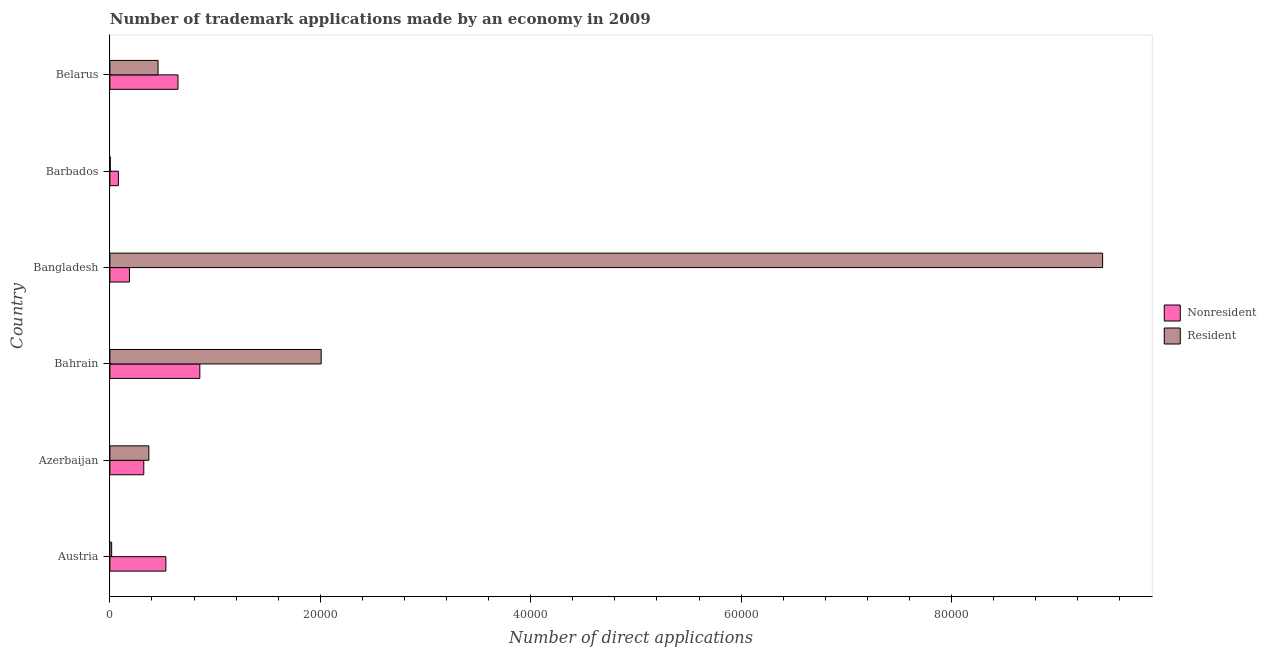Are the number of bars per tick equal to the number of legend labels?
Your answer should be compact. Yes. Are the number of bars on each tick of the Y-axis equal?
Give a very brief answer. Yes. How many bars are there on the 5th tick from the top?
Make the answer very short. 2. How many bars are there on the 2nd tick from the bottom?
Give a very brief answer. 2. What is the label of the 2nd group of bars from the top?
Offer a terse response. Barbados. In how many cases, is the number of bars for a given country not equal to the number of legend labels?
Give a very brief answer. 0. What is the number of trademark applications made by non residents in Azerbaijan?
Give a very brief answer. 3221. Across all countries, what is the maximum number of trademark applications made by residents?
Provide a short and direct response. 9.44e+04. Across all countries, what is the minimum number of trademark applications made by non residents?
Provide a succinct answer. 808. In which country was the number of trademark applications made by residents maximum?
Provide a succinct answer. Bangladesh. In which country was the number of trademark applications made by non residents minimum?
Your answer should be very brief. Barbados. What is the total number of trademark applications made by non residents in the graph?
Offer a very short reply. 2.62e+04. What is the difference between the number of trademark applications made by residents in Austria and that in Barbados?
Offer a terse response. 133. What is the difference between the number of trademark applications made by residents in Bangladesh and the number of trademark applications made by non residents in Belarus?
Make the answer very short. 8.79e+04. What is the average number of trademark applications made by residents per country?
Make the answer very short. 2.05e+04. What is the difference between the number of trademark applications made by non residents and number of trademark applications made by residents in Austria?
Your answer should be compact. 5153. In how many countries, is the number of trademark applications made by non residents greater than 28000 ?
Give a very brief answer. 0. What is the ratio of the number of trademark applications made by non residents in Bahrain to that in Belarus?
Your answer should be compact. 1.32. Is the number of trademark applications made by non residents in Barbados less than that in Belarus?
Your answer should be compact. Yes. What is the difference between the highest and the second highest number of trademark applications made by residents?
Give a very brief answer. 7.43e+04. What is the difference between the highest and the lowest number of trademark applications made by non residents?
Your response must be concise. 7740. Is the sum of the number of trademark applications made by residents in Austria and Bangladesh greater than the maximum number of trademark applications made by non residents across all countries?
Ensure brevity in your answer.  Yes. What does the 1st bar from the top in Austria represents?
Ensure brevity in your answer.  Resident. What does the 2nd bar from the bottom in Bangladesh represents?
Your answer should be very brief. Resident. How many bars are there?
Your response must be concise. 12. Are all the bars in the graph horizontal?
Offer a terse response. Yes. How many countries are there in the graph?
Keep it short and to the point. 6. Are the values on the major ticks of X-axis written in scientific E-notation?
Offer a terse response. No. Does the graph contain grids?
Your answer should be very brief. No. How many legend labels are there?
Your answer should be very brief. 2. What is the title of the graph?
Ensure brevity in your answer.  Number of trademark applications made by an economy in 2009. What is the label or title of the X-axis?
Provide a succinct answer. Number of direct applications. What is the Number of direct applications in Nonresident in Austria?
Ensure brevity in your answer.  5321. What is the Number of direct applications of Resident in Austria?
Ensure brevity in your answer.  168. What is the Number of direct applications of Nonresident in Azerbaijan?
Give a very brief answer. 3221. What is the Number of direct applications in Resident in Azerbaijan?
Provide a succinct answer. 3703. What is the Number of direct applications of Nonresident in Bahrain?
Offer a very short reply. 8548. What is the Number of direct applications in Resident in Bahrain?
Offer a very short reply. 2.01e+04. What is the Number of direct applications of Nonresident in Bangladesh?
Make the answer very short. 1859. What is the Number of direct applications in Resident in Bangladesh?
Provide a short and direct response. 9.44e+04. What is the Number of direct applications in Nonresident in Barbados?
Your answer should be very brief. 808. What is the Number of direct applications in Nonresident in Belarus?
Keep it short and to the point. 6473. What is the Number of direct applications in Resident in Belarus?
Your answer should be very brief. 4578. Across all countries, what is the maximum Number of direct applications of Nonresident?
Offer a very short reply. 8548. Across all countries, what is the maximum Number of direct applications of Resident?
Your response must be concise. 9.44e+04. Across all countries, what is the minimum Number of direct applications in Nonresident?
Your answer should be compact. 808. What is the total Number of direct applications of Nonresident in the graph?
Your answer should be compact. 2.62e+04. What is the total Number of direct applications of Resident in the graph?
Keep it short and to the point. 1.23e+05. What is the difference between the Number of direct applications of Nonresident in Austria and that in Azerbaijan?
Your answer should be compact. 2100. What is the difference between the Number of direct applications in Resident in Austria and that in Azerbaijan?
Your answer should be compact. -3535. What is the difference between the Number of direct applications in Nonresident in Austria and that in Bahrain?
Provide a short and direct response. -3227. What is the difference between the Number of direct applications in Resident in Austria and that in Bahrain?
Make the answer very short. -1.99e+04. What is the difference between the Number of direct applications in Nonresident in Austria and that in Bangladesh?
Offer a terse response. 3462. What is the difference between the Number of direct applications in Resident in Austria and that in Bangladesh?
Ensure brevity in your answer.  -9.42e+04. What is the difference between the Number of direct applications in Nonresident in Austria and that in Barbados?
Offer a terse response. 4513. What is the difference between the Number of direct applications of Resident in Austria and that in Barbados?
Give a very brief answer. 133. What is the difference between the Number of direct applications in Nonresident in Austria and that in Belarus?
Offer a very short reply. -1152. What is the difference between the Number of direct applications in Resident in Austria and that in Belarus?
Offer a very short reply. -4410. What is the difference between the Number of direct applications in Nonresident in Azerbaijan and that in Bahrain?
Offer a very short reply. -5327. What is the difference between the Number of direct applications in Resident in Azerbaijan and that in Bahrain?
Your response must be concise. -1.64e+04. What is the difference between the Number of direct applications in Nonresident in Azerbaijan and that in Bangladesh?
Offer a very short reply. 1362. What is the difference between the Number of direct applications of Resident in Azerbaijan and that in Bangladesh?
Your answer should be compact. -9.07e+04. What is the difference between the Number of direct applications of Nonresident in Azerbaijan and that in Barbados?
Ensure brevity in your answer.  2413. What is the difference between the Number of direct applications in Resident in Azerbaijan and that in Barbados?
Keep it short and to the point. 3668. What is the difference between the Number of direct applications in Nonresident in Azerbaijan and that in Belarus?
Make the answer very short. -3252. What is the difference between the Number of direct applications in Resident in Azerbaijan and that in Belarus?
Ensure brevity in your answer.  -875. What is the difference between the Number of direct applications in Nonresident in Bahrain and that in Bangladesh?
Give a very brief answer. 6689. What is the difference between the Number of direct applications of Resident in Bahrain and that in Bangladesh?
Offer a very short reply. -7.43e+04. What is the difference between the Number of direct applications in Nonresident in Bahrain and that in Barbados?
Give a very brief answer. 7740. What is the difference between the Number of direct applications of Resident in Bahrain and that in Barbados?
Your answer should be very brief. 2.00e+04. What is the difference between the Number of direct applications of Nonresident in Bahrain and that in Belarus?
Your response must be concise. 2075. What is the difference between the Number of direct applications of Resident in Bahrain and that in Belarus?
Make the answer very short. 1.55e+04. What is the difference between the Number of direct applications in Nonresident in Bangladesh and that in Barbados?
Your answer should be compact. 1051. What is the difference between the Number of direct applications in Resident in Bangladesh and that in Barbados?
Keep it short and to the point. 9.43e+04. What is the difference between the Number of direct applications of Nonresident in Bangladesh and that in Belarus?
Offer a very short reply. -4614. What is the difference between the Number of direct applications of Resident in Bangladesh and that in Belarus?
Keep it short and to the point. 8.98e+04. What is the difference between the Number of direct applications of Nonresident in Barbados and that in Belarus?
Keep it short and to the point. -5665. What is the difference between the Number of direct applications of Resident in Barbados and that in Belarus?
Ensure brevity in your answer.  -4543. What is the difference between the Number of direct applications of Nonresident in Austria and the Number of direct applications of Resident in Azerbaijan?
Your answer should be compact. 1618. What is the difference between the Number of direct applications of Nonresident in Austria and the Number of direct applications of Resident in Bahrain?
Provide a succinct answer. -1.48e+04. What is the difference between the Number of direct applications in Nonresident in Austria and the Number of direct applications in Resident in Bangladesh?
Keep it short and to the point. -8.90e+04. What is the difference between the Number of direct applications in Nonresident in Austria and the Number of direct applications in Resident in Barbados?
Give a very brief answer. 5286. What is the difference between the Number of direct applications of Nonresident in Austria and the Number of direct applications of Resident in Belarus?
Provide a succinct answer. 743. What is the difference between the Number of direct applications in Nonresident in Azerbaijan and the Number of direct applications in Resident in Bahrain?
Your answer should be very brief. -1.69e+04. What is the difference between the Number of direct applications in Nonresident in Azerbaijan and the Number of direct applications in Resident in Bangladesh?
Ensure brevity in your answer.  -9.11e+04. What is the difference between the Number of direct applications of Nonresident in Azerbaijan and the Number of direct applications of Resident in Barbados?
Make the answer very short. 3186. What is the difference between the Number of direct applications of Nonresident in Azerbaijan and the Number of direct applications of Resident in Belarus?
Give a very brief answer. -1357. What is the difference between the Number of direct applications of Nonresident in Bahrain and the Number of direct applications of Resident in Bangladesh?
Your answer should be very brief. -8.58e+04. What is the difference between the Number of direct applications of Nonresident in Bahrain and the Number of direct applications of Resident in Barbados?
Your answer should be very brief. 8513. What is the difference between the Number of direct applications of Nonresident in Bahrain and the Number of direct applications of Resident in Belarus?
Your answer should be very brief. 3970. What is the difference between the Number of direct applications of Nonresident in Bangladesh and the Number of direct applications of Resident in Barbados?
Your response must be concise. 1824. What is the difference between the Number of direct applications in Nonresident in Bangladesh and the Number of direct applications in Resident in Belarus?
Your response must be concise. -2719. What is the difference between the Number of direct applications of Nonresident in Barbados and the Number of direct applications of Resident in Belarus?
Your answer should be very brief. -3770. What is the average Number of direct applications in Nonresident per country?
Keep it short and to the point. 4371.67. What is the average Number of direct applications of Resident per country?
Offer a terse response. 2.05e+04. What is the difference between the Number of direct applications in Nonresident and Number of direct applications in Resident in Austria?
Ensure brevity in your answer.  5153. What is the difference between the Number of direct applications in Nonresident and Number of direct applications in Resident in Azerbaijan?
Offer a terse response. -482. What is the difference between the Number of direct applications in Nonresident and Number of direct applications in Resident in Bahrain?
Offer a terse response. -1.15e+04. What is the difference between the Number of direct applications in Nonresident and Number of direct applications in Resident in Bangladesh?
Give a very brief answer. -9.25e+04. What is the difference between the Number of direct applications of Nonresident and Number of direct applications of Resident in Barbados?
Make the answer very short. 773. What is the difference between the Number of direct applications in Nonresident and Number of direct applications in Resident in Belarus?
Your answer should be compact. 1895. What is the ratio of the Number of direct applications in Nonresident in Austria to that in Azerbaijan?
Provide a succinct answer. 1.65. What is the ratio of the Number of direct applications of Resident in Austria to that in Azerbaijan?
Keep it short and to the point. 0.05. What is the ratio of the Number of direct applications in Nonresident in Austria to that in Bahrain?
Your answer should be very brief. 0.62. What is the ratio of the Number of direct applications in Resident in Austria to that in Bahrain?
Make the answer very short. 0.01. What is the ratio of the Number of direct applications of Nonresident in Austria to that in Bangladesh?
Offer a terse response. 2.86. What is the ratio of the Number of direct applications in Resident in Austria to that in Bangladesh?
Offer a very short reply. 0. What is the ratio of the Number of direct applications of Nonresident in Austria to that in Barbados?
Provide a succinct answer. 6.59. What is the ratio of the Number of direct applications in Resident in Austria to that in Barbados?
Keep it short and to the point. 4.8. What is the ratio of the Number of direct applications in Nonresident in Austria to that in Belarus?
Keep it short and to the point. 0.82. What is the ratio of the Number of direct applications in Resident in Austria to that in Belarus?
Your answer should be very brief. 0.04. What is the ratio of the Number of direct applications of Nonresident in Azerbaijan to that in Bahrain?
Make the answer very short. 0.38. What is the ratio of the Number of direct applications of Resident in Azerbaijan to that in Bahrain?
Make the answer very short. 0.18. What is the ratio of the Number of direct applications of Nonresident in Azerbaijan to that in Bangladesh?
Offer a terse response. 1.73. What is the ratio of the Number of direct applications of Resident in Azerbaijan to that in Bangladesh?
Your answer should be compact. 0.04. What is the ratio of the Number of direct applications in Nonresident in Azerbaijan to that in Barbados?
Provide a succinct answer. 3.99. What is the ratio of the Number of direct applications of Resident in Azerbaijan to that in Barbados?
Keep it short and to the point. 105.8. What is the ratio of the Number of direct applications in Nonresident in Azerbaijan to that in Belarus?
Ensure brevity in your answer.  0.5. What is the ratio of the Number of direct applications of Resident in Azerbaijan to that in Belarus?
Ensure brevity in your answer.  0.81. What is the ratio of the Number of direct applications of Nonresident in Bahrain to that in Bangladesh?
Keep it short and to the point. 4.6. What is the ratio of the Number of direct applications in Resident in Bahrain to that in Bangladesh?
Your answer should be compact. 0.21. What is the ratio of the Number of direct applications of Nonresident in Bahrain to that in Barbados?
Ensure brevity in your answer.  10.58. What is the ratio of the Number of direct applications in Resident in Bahrain to that in Barbados?
Your response must be concise. 573.8. What is the ratio of the Number of direct applications of Nonresident in Bahrain to that in Belarus?
Your response must be concise. 1.32. What is the ratio of the Number of direct applications in Resident in Bahrain to that in Belarus?
Ensure brevity in your answer.  4.39. What is the ratio of the Number of direct applications of Nonresident in Bangladesh to that in Barbados?
Offer a very short reply. 2.3. What is the ratio of the Number of direct applications in Resident in Bangladesh to that in Barbados?
Offer a terse response. 2696.03. What is the ratio of the Number of direct applications in Nonresident in Bangladesh to that in Belarus?
Offer a very short reply. 0.29. What is the ratio of the Number of direct applications in Resident in Bangladesh to that in Belarus?
Offer a very short reply. 20.61. What is the ratio of the Number of direct applications in Nonresident in Barbados to that in Belarus?
Your answer should be very brief. 0.12. What is the ratio of the Number of direct applications of Resident in Barbados to that in Belarus?
Give a very brief answer. 0.01. What is the difference between the highest and the second highest Number of direct applications in Nonresident?
Ensure brevity in your answer.  2075. What is the difference between the highest and the second highest Number of direct applications in Resident?
Your answer should be compact. 7.43e+04. What is the difference between the highest and the lowest Number of direct applications of Nonresident?
Your answer should be very brief. 7740. What is the difference between the highest and the lowest Number of direct applications of Resident?
Make the answer very short. 9.43e+04. 